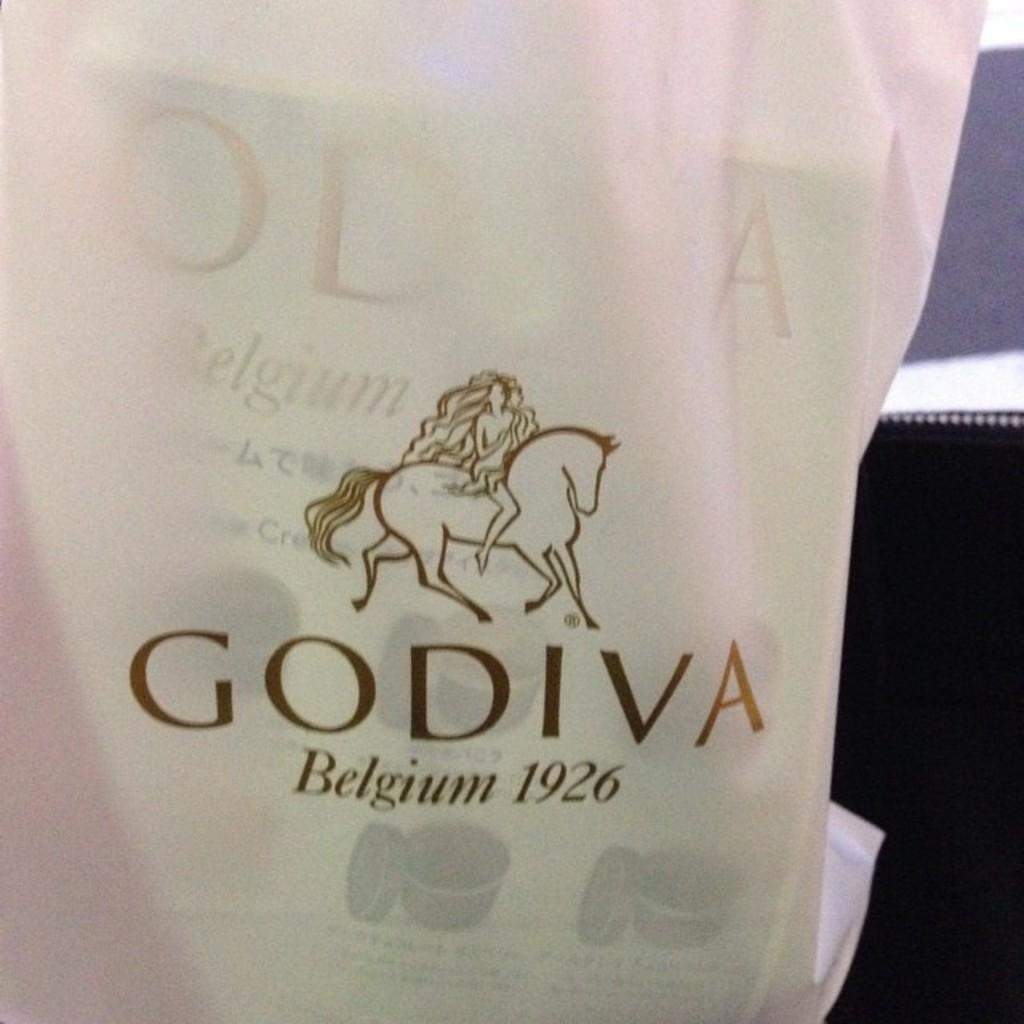<image>
Describe the image concisely. A Godiva bag with a horse on it 